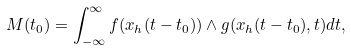Convert formula to latex. <formula><loc_0><loc_0><loc_500><loc_500>M ( t _ { 0 } ) = \int _ { - \infty } ^ { \infty } { f } ( { x } _ { h } ( t - t _ { 0 } ) ) \wedge { g } ( { x } _ { h } ( t - t _ { 0 } ) , t ) d t ,</formula> 